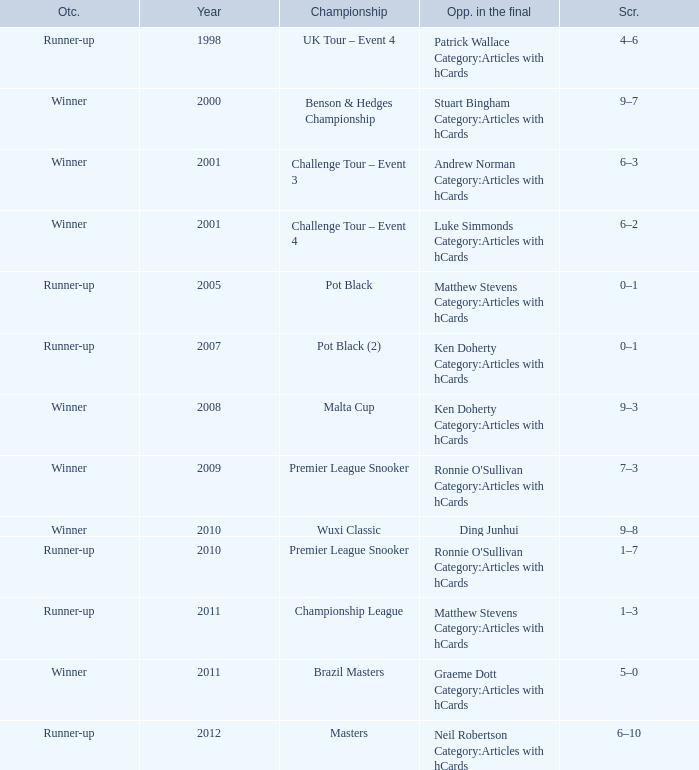What was Shaun Murphy's outcome in the Premier League Snooker championship held before 2010? Winner. 